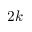Convert formula to latex. <formula><loc_0><loc_0><loc_500><loc_500>2 k</formula> 